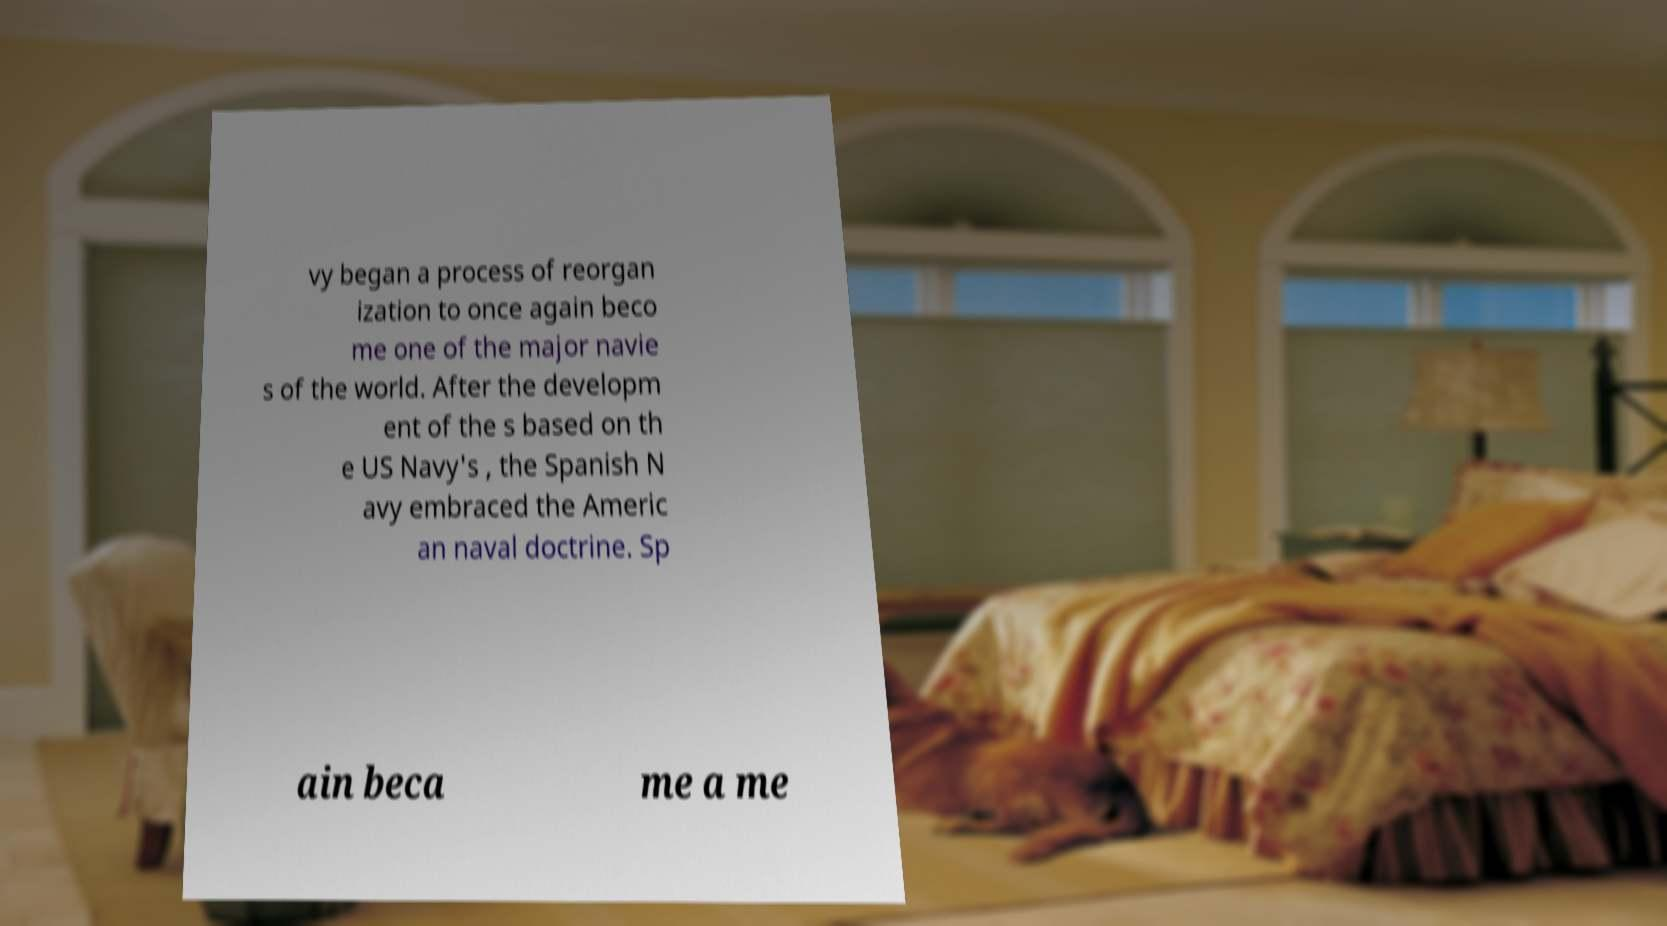Please read and relay the text visible in this image. What does it say? vy began a process of reorgan ization to once again beco me one of the major navie s of the world. After the developm ent of the s based on th e US Navy's , the Spanish N avy embraced the Americ an naval doctrine. Sp ain beca me a me 